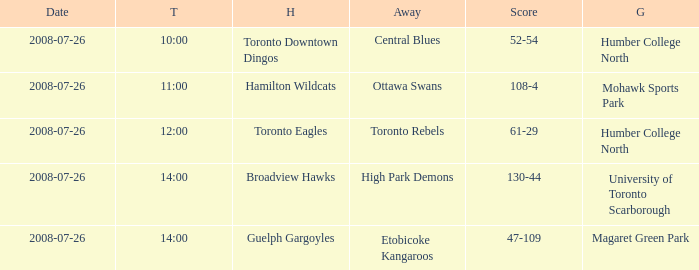When did the High Park Demons play Away? 2008-07-26. Write the full table. {'header': ['Date', 'T', 'H', 'Away', 'Score', 'G'], 'rows': [['2008-07-26', '10:00', 'Toronto Downtown Dingos', 'Central Blues', '52-54', 'Humber College North'], ['2008-07-26', '11:00', 'Hamilton Wildcats', 'Ottawa Swans', '108-4', 'Mohawk Sports Park'], ['2008-07-26', '12:00', 'Toronto Eagles', 'Toronto Rebels', '61-29', 'Humber College North'], ['2008-07-26', '14:00', 'Broadview Hawks', 'High Park Demons', '130-44', 'University of Toronto Scarborough'], ['2008-07-26', '14:00', 'Guelph Gargoyles', 'Etobicoke Kangaroos', '47-109', 'Magaret Green Park']]} 